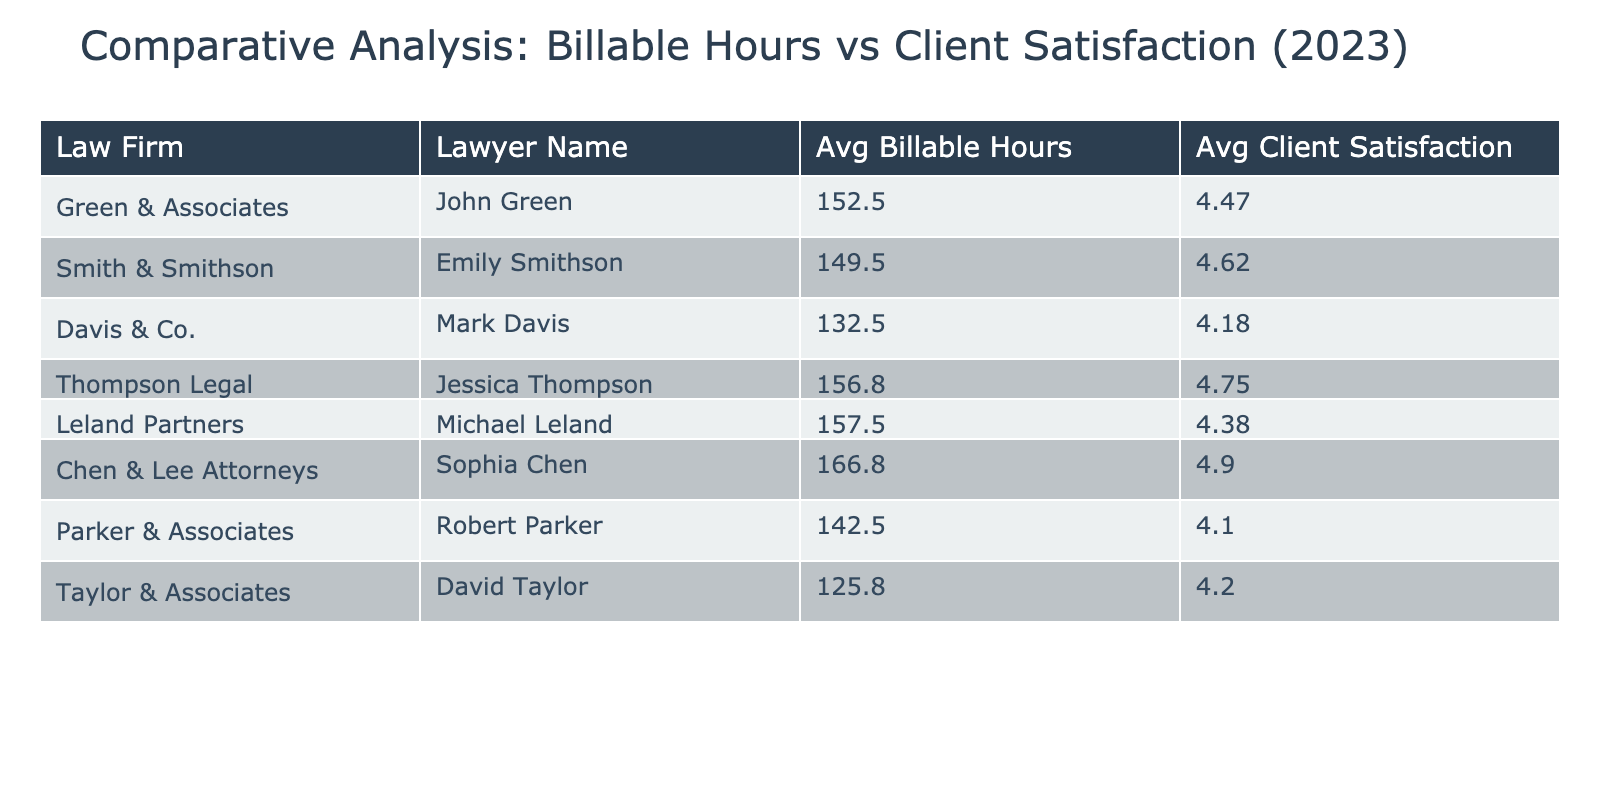What is the average billable hours for John Green? To find the average, we sum John Green's billable hours across the four quarters (150 + 160 + 145 + 155) = 610. Then, we divide that by the number of quarters, which is 4. Thus, the average is 610 / 4 = 152.5, which rounds to 153.
Answer: 153 Which lawyer has the highest average client satisfaction rating? We need to calculate the average client satisfaction for each lawyer. The averages for each lawyer are: John Green - 4.5, Emily Smithson - 4.625, Mark Davis - 4.175, Jessica Thompson - 4.75, Michael Leland - 4.4, Sophia Chen - 4.725, Robert Parker - 4.1, David Taylor - 4.225. The highest average client satisfaction is 4.75 for Jessica Thompson.
Answer: Jessica Thompson Did Michael Leland bill more hours than Robert Parker in Q2? We compare the billable hours for the second quarter. Michael Leland billed 150 hours in Q2, while Robert Parker billed 140 hours. Since 150 is greater than 140, the statement is true.
Answer: Yes What is the difference between the average billable hours of Jessica Thompson and Mark Davis? The averages are: Jessica Thompson - 153.25 and Mark Davis - 132.5. The difference is calculated by subtracting Mark Davis's average from Jessica Thompson's: 153.25 - 132.5 = 20.75. Rounding this, we find the difference is approximately 21 hours.
Answer: 21 Is it true that all lawyers have an average client satisfaction rating above 4.0? We look at the averages: John Green - 4.5, Emily Smithson - 4.625, Mark Davis - 4.175, Jessica Thompson - 4.75, Michael Leland - 4.4, Sophia Chen - 4.725, Robert Parker - 4.1, David Taylor - 4.225. All lawyers indeed exceed 4.0 in their average ratings.
Answer: Yes Who has a lower average client satisfaction: John Green or Leland Partners? We compare the averages: John Green has an average of 4.5 and Michael Leland from Leland Partners has an average of 4.4. Since 4.4 is less than 4.5, Michael Leland's firm has a lower average.
Answer: Leland Partners What is the average client satisfaction rating of Chen & Lee Attorneys? To calculate the average for Sophia Chen, we sum her satisfaction ratings (4.9 + 4.8 + 5.0 + 4.9) = 19.6, and then divide by 4. Thus, 19.6 / 4 = 4.9.
Answer: 4.9 Which firm has the highest total billable hours for the year? We calculate total billable hours for each lawyer: John Green - 610, Emily Smithson - 598, Mark Davis - 530, Jessica Thompson - 627, Michael Leland - 630, Sophia Chen - 667, Robert Parker - 570, David Taylor - 503. The highest total is 667 hours for Sophia Chen at Chen & Lee Attorneys.
Answer: Chen & Lee Attorneys What is the average of the average billable hours of all lawyers? The average billable hours for each lawyer are: John Green - 152.5, Emily Smithson - 148.75, Mark Davis - 132.5, Jessica Thompson - 153.25, Michael Leland - 157.5, Sophia Chen - 167.5, Robert Parker - 145, David Taylor - 130. The total average is (152.5 + 148.75 + 132.5 + 153.25 + 157.5 + 167.5 + 145 + 130) / 8 = 145.5.
Answer: 145.5 